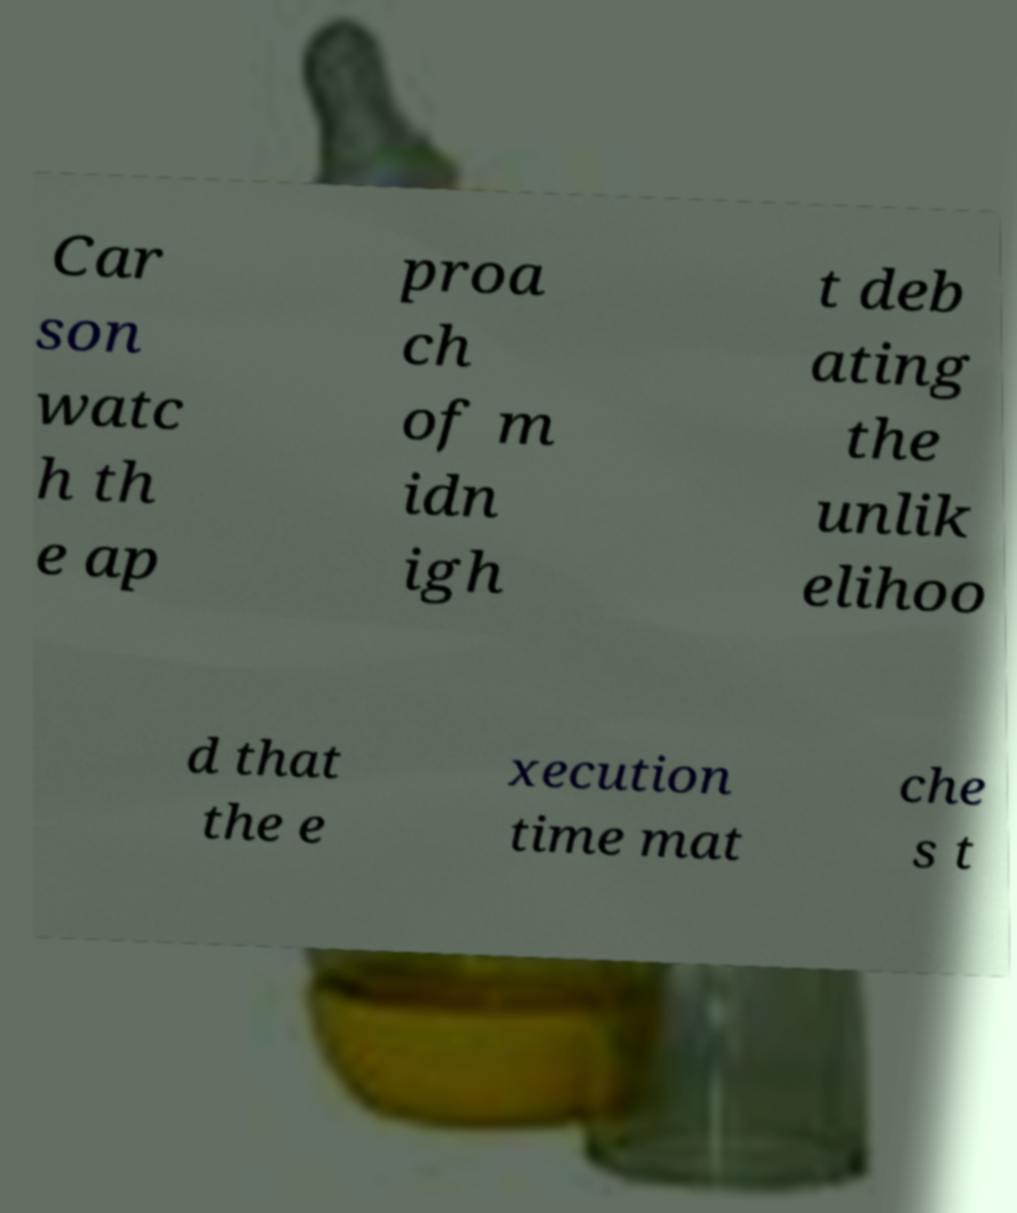Could you assist in decoding the text presented in this image and type it out clearly? Car son watc h th e ap proa ch of m idn igh t deb ating the unlik elihoo d that the e xecution time mat che s t 